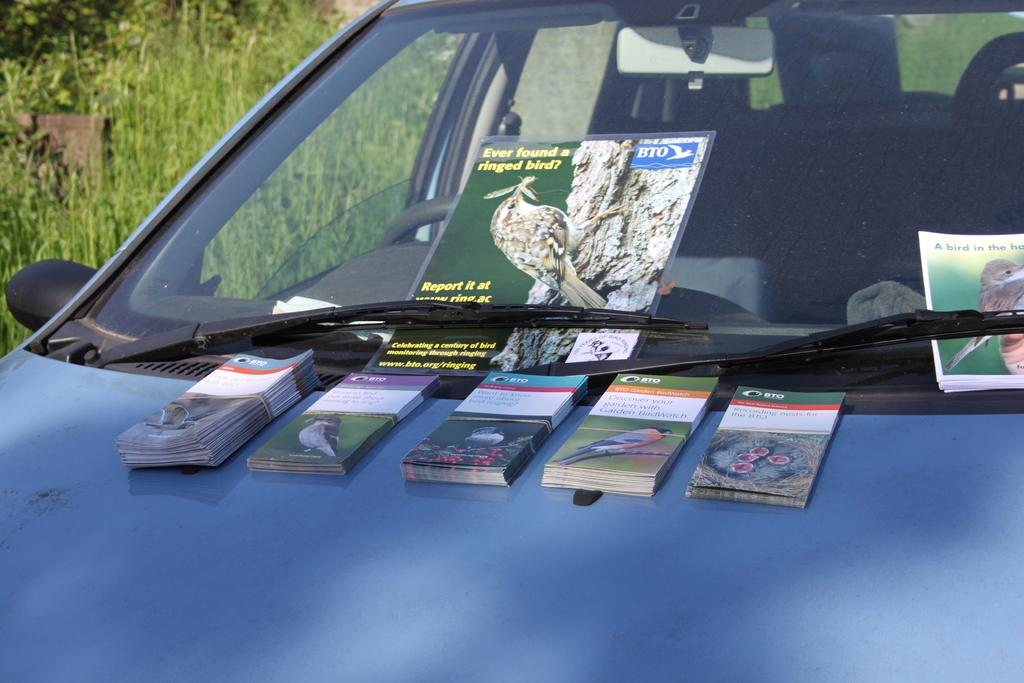What is placed on the car in the image? There are papers on a car in the image. What type of surface can be seen on the ground in the image? There is grass on the ground in the image. What color is the curtain hanging in the background of the image? There is no curtain present in the image. How does the car express anger in the image? Cars do not have the ability to express emotions like anger, and there is no indication of anger in the image. 